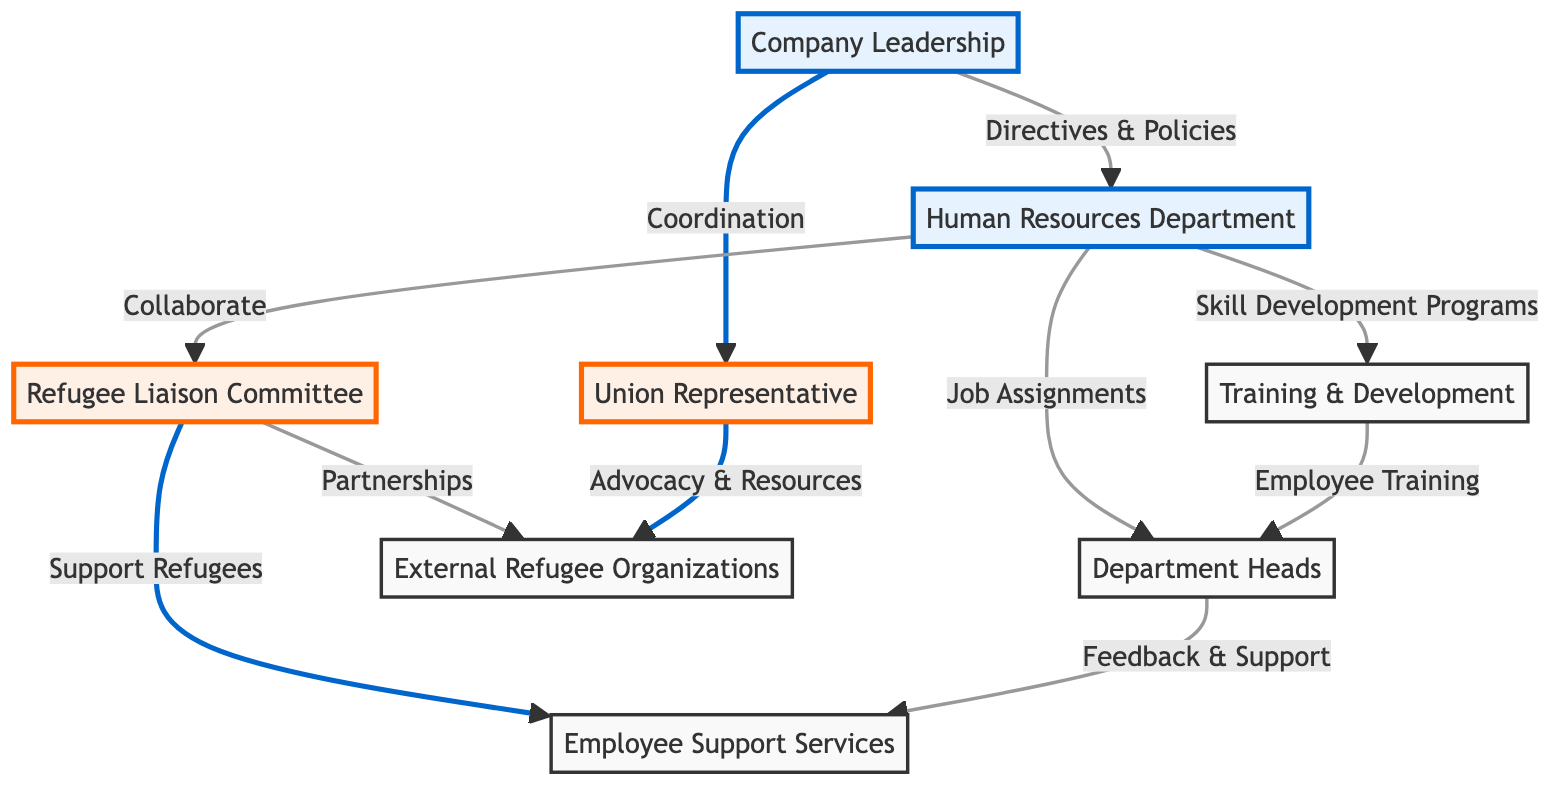What is the central committee focused on refugee support? The diagram identifies the "Refugee Liaison Committee" as the specific committee responsible for supporting refugees within the organizational structure. This committee is shown as a distinct node connected to various other departments, highlighting its role.
Answer: Refugee Liaison Committee How many primary departments are connected to the Company Leadership? The Company Leadership connects to two primary departments: Human Resources and Union Representative. The connections are explicitly represented by arrows originating from the Company Leadership node.
Answer: 2 Which department collaborates with the Refugee Liaison Committee? The diagram indicates that the Human Resources Department collaborates with the Refugee Liaison Committee. This relationship is depicted through a direct link showing the collaborative action between these two entities.
Answer: Human Resources Department What service does the Refugee Liaison Committee provide to employees? The Refugee Liaison Committee supports refugee employees, which is indicated on the diagram where it points towards Employee Support Services. This highlights the committee's function in enhancing employee welfare.
Answer: Support Refugees What role does the Union Representative play in relation to external organizations? The diagram notes that the Union Representative advocates for and accesses resources from external refugee organizations. This indicates a vital role in linking the internal union efforts with external support systems.
Answer: Advocacy & Resources What is the relationship between the Human Resources Department and Training & Development? The Human Resources Department is linked to Training & Development through a collaboration focused on skill development programs, highlighting this essential function within the organizational framework.
Answer: Skill Development Programs How many departments are involved in training according to the diagram? The diagram shows that two departments are involved in the training process: the Human Resources Department and the Training & Development unit. Their collaboration is highlighted through direct connections appearing on the flowchart.
Answer: 2 Which committee partners with external organizations? The Refugee Liaison Committee forms partnerships with external refugee organizations, as indicated by the direct link from the committee node to the external organizations node, reflecting its outreach efforts.
Answer: Partnerships What feedback mechanism is present between Department Heads and Employee Support Services? The Department Heads provide feedback and support to the Employee Support Services, represented by a direct connection in the diagram, showcasing communication and assistance flow within the organizational structure.
Answer: Feedback & Support 